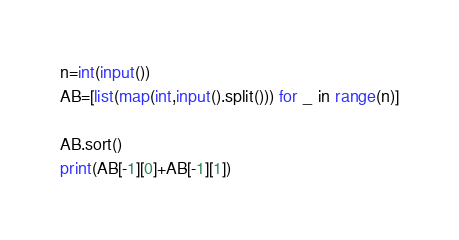<code> <loc_0><loc_0><loc_500><loc_500><_Python_>n=int(input())
AB=[list(map(int,input().split())) for _ in range(n)]

AB.sort()
print(AB[-1][0]+AB[-1][1])</code> 